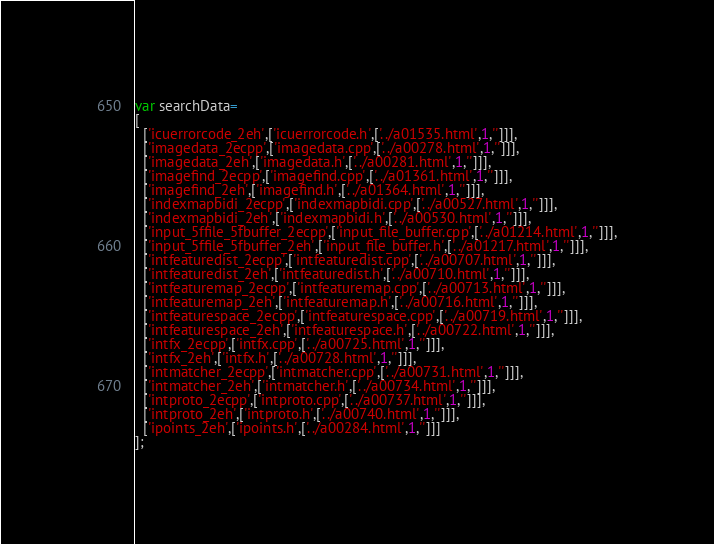<code> <loc_0><loc_0><loc_500><loc_500><_JavaScript_>var searchData=
[
  ['icuerrorcode_2eh',['icuerrorcode.h',['../a01535.html',1,'']]],
  ['imagedata_2ecpp',['imagedata.cpp',['../a00278.html',1,'']]],
  ['imagedata_2eh',['imagedata.h',['../a00281.html',1,'']]],
  ['imagefind_2ecpp',['imagefind.cpp',['../a01361.html',1,'']]],
  ['imagefind_2eh',['imagefind.h',['../a01364.html',1,'']]],
  ['indexmapbidi_2ecpp',['indexmapbidi.cpp',['../a00527.html',1,'']]],
  ['indexmapbidi_2eh',['indexmapbidi.h',['../a00530.html',1,'']]],
  ['input_5ffile_5fbuffer_2ecpp',['input_file_buffer.cpp',['../a01214.html',1,'']]],
  ['input_5ffile_5fbuffer_2eh',['input_file_buffer.h',['../a01217.html',1,'']]],
  ['intfeaturedist_2ecpp',['intfeaturedist.cpp',['../a00707.html',1,'']]],
  ['intfeaturedist_2eh',['intfeaturedist.h',['../a00710.html',1,'']]],
  ['intfeaturemap_2ecpp',['intfeaturemap.cpp',['../a00713.html',1,'']]],
  ['intfeaturemap_2eh',['intfeaturemap.h',['../a00716.html',1,'']]],
  ['intfeaturespace_2ecpp',['intfeaturespace.cpp',['../a00719.html',1,'']]],
  ['intfeaturespace_2eh',['intfeaturespace.h',['../a00722.html',1,'']]],
  ['intfx_2ecpp',['intfx.cpp',['../a00725.html',1,'']]],
  ['intfx_2eh',['intfx.h',['../a00728.html',1,'']]],
  ['intmatcher_2ecpp',['intmatcher.cpp',['../a00731.html',1,'']]],
  ['intmatcher_2eh',['intmatcher.h',['../a00734.html',1,'']]],
  ['intproto_2ecpp',['intproto.cpp',['../a00737.html',1,'']]],
  ['intproto_2eh',['intproto.h',['../a00740.html',1,'']]],
  ['ipoints_2eh',['ipoints.h',['../a00284.html',1,'']]]
];
</code> 